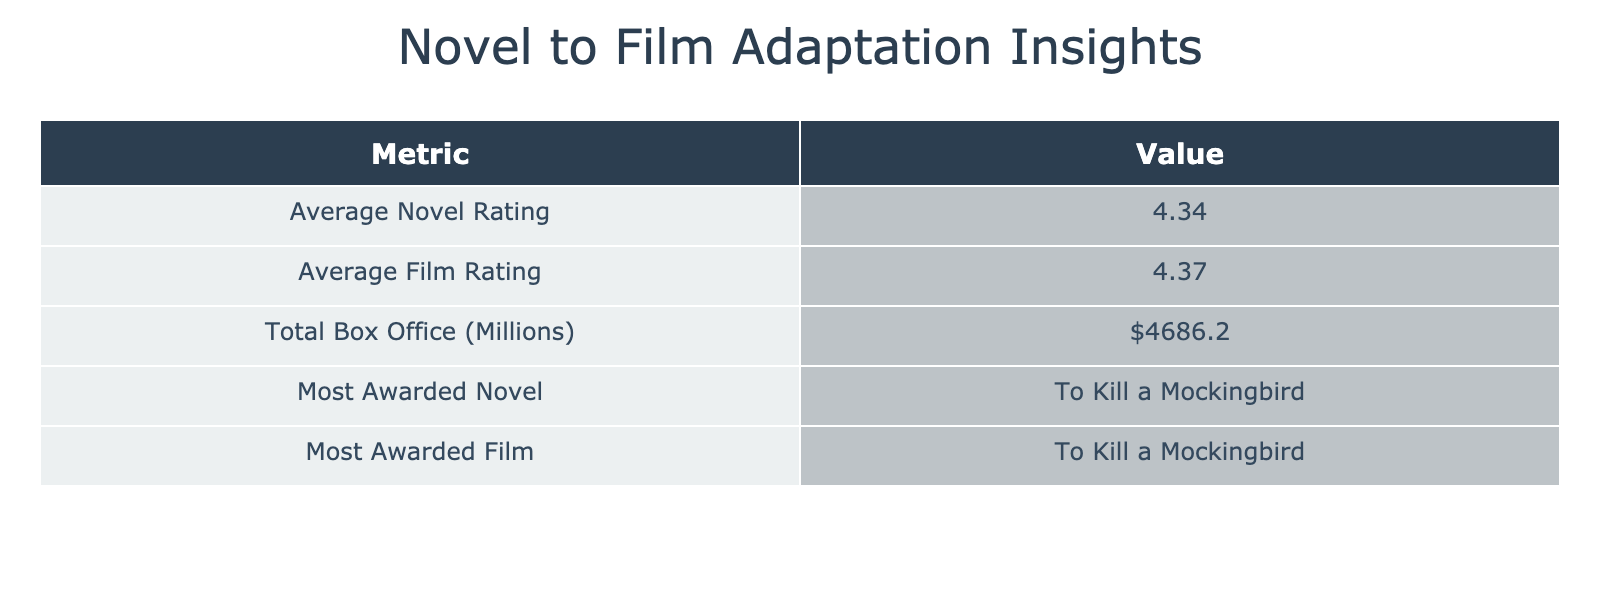What is the average novel rating across the adaptations? To find the average novel rating, add the Novel Ratings: 4.8 + 4.6 + 4.2 + 4.5 + 4.7 + 4.3 + 4.4 + 4.3 + 4.1 + 4.2 + 4.0 + 4.4 + 4.1 = 54.0. Since there are 12 adaptations, divide the total by 12: 54.0 / 12 = 4.5.
Answer: 4.5 Which film adaptation received the most awards? To determine which film received the most awards, look for the highest number of Oscars listed in the Awards_Film column. The Shawshank Redemption and The Lord of the Rings: The Fellowship of the Ring both received 4 Oscars, which is the highest among all adaptations.
Answer: The Shawshank Redemption and The Lord of the Rings: The Fellowship of the Ring Is the average film rating higher than the average novel rating? First, calculate average film rating: 4.3 + 4.7 + 4.5 + 4.9 + 4.8 + 3.9 + 4.7 + 4.6 + 4.2 + 4.4 + 4.1 + 4.2 + 4.1 = 59.6. Now find the average: 59.6 / 12 = 4.9667, which is higher than the average novel rating of 4.5 calculated previously.
Answer: Yes How much total box office revenue did the adaptations generate? To find the total box office revenue, sum all values from the Box_Office_Millions column: 13.1 + 245.1 + 100.9 + 58.3 + 871.5 + 353.6 + 112.0 + 272.7 + 369.3 + 171.6 + 216.6 + 630.2 + 533.0 = 3380.4.
Answer: 3380.4 million Did any film adaptation win the Pulitzer Prize for its original novel? Check the Awards_Novel column for any mention of the Pulitzer Prize. From the data, both To Kill a Mockingbird and No Country for Old Men won the Pulitzer Prize for their respective novels.
Answer: Yes 